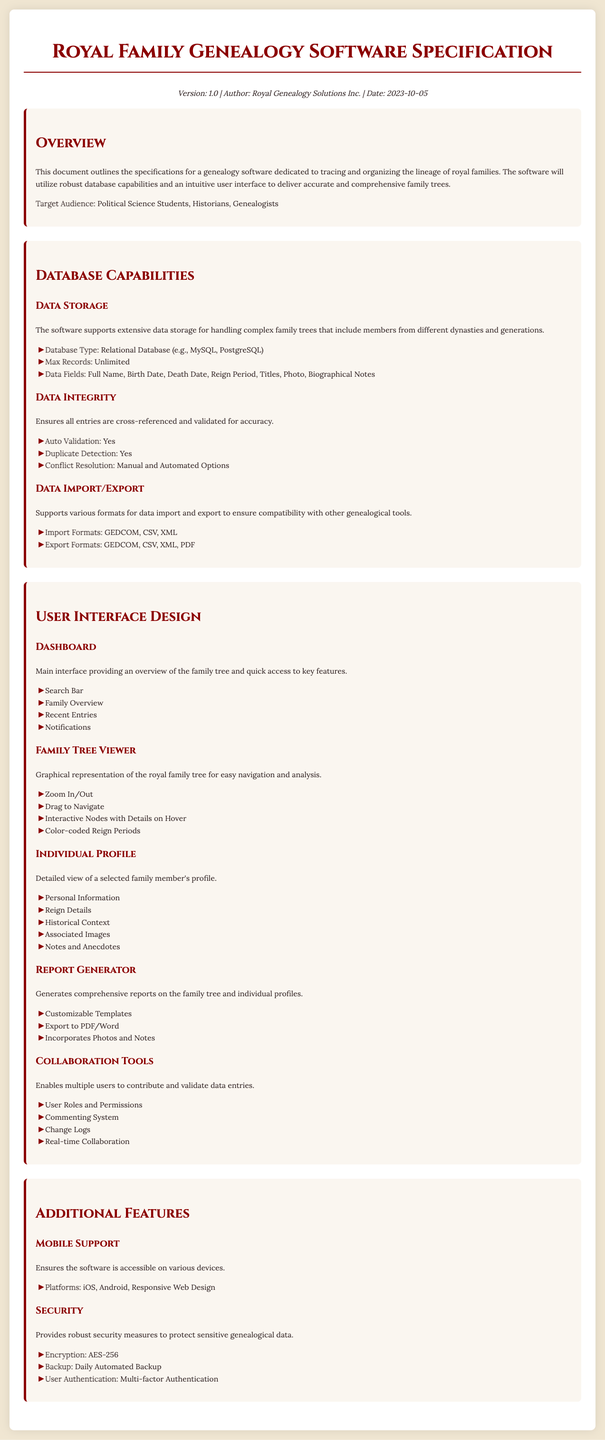What is the version of the software? The version of the software is specified in the metadata section of the document.
Answer: 1.0 What types of database does the software support? The document specifies the database type under the Data Storage section.
Answer: Relational Database What is the maximum number of records the software can handle? The maximum number of records is mentioned in the Data Storage section.
Answer: Unlimited What feature allows users to generate reports? The document outlines the features under the User Interface Design section, specifically related to report generation.
Answer: Report Generator Which encryption method is used for security? The security features of the software include specific methods mentioned in the document.
Answer: AES-256 How many formats are supported for data import? The document lists the supported formats under the Data Import/Export section.
Answer: Three What type of users does the software target? The target audience is mentioned in the Overview section of the document.
Answer: Political Science Students, Historians, Genealogists Which mobile platforms are supported by the software? This information is listed under the Mobile Support section.
Answer: iOS, Android What is featured in the Family Tree Viewer? The Family Tree Viewer section describes specific capabilities related to visualizing the family tree.
Answer: Graphical representation 